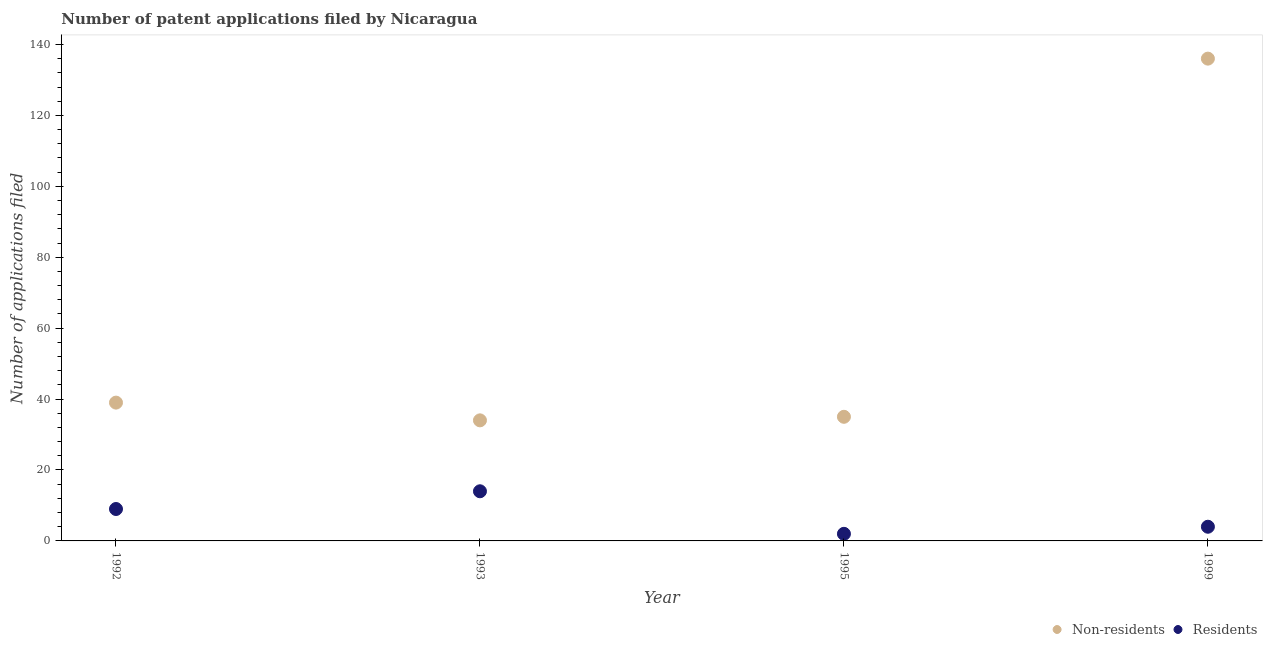How many different coloured dotlines are there?
Your answer should be compact. 2. Is the number of dotlines equal to the number of legend labels?
Your answer should be very brief. Yes. What is the number of patent applications by non residents in 1993?
Provide a succinct answer. 34. Across all years, what is the maximum number of patent applications by non residents?
Offer a terse response. 136. Across all years, what is the minimum number of patent applications by residents?
Provide a short and direct response. 2. In which year was the number of patent applications by non residents maximum?
Make the answer very short. 1999. What is the total number of patent applications by non residents in the graph?
Your answer should be compact. 244. What is the difference between the number of patent applications by residents in 1995 and that in 1999?
Offer a terse response. -2. What is the difference between the number of patent applications by non residents in 1999 and the number of patent applications by residents in 1992?
Provide a succinct answer. 127. What is the average number of patent applications by residents per year?
Your answer should be compact. 7.25. In the year 1999, what is the difference between the number of patent applications by non residents and number of patent applications by residents?
Offer a terse response. 132. What is the ratio of the number of patent applications by non residents in 1992 to that in 1995?
Provide a succinct answer. 1.11. Is the number of patent applications by non residents in 1992 less than that in 1993?
Your answer should be compact. No. What is the difference between the highest and the second highest number of patent applications by non residents?
Give a very brief answer. 97. What is the difference between the highest and the lowest number of patent applications by residents?
Give a very brief answer. 12. In how many years, is the number of patent applications by non residents greater than the average number of patent applications by non residents taken over all years?
Give a very brief answer. 1. How many dotlines are there?
Your answer should be compact. 2. How many years are there in the graph?
Your response must be concise. 4. Are the values on the major ticks of Y-axis written in scientific E-notation?
Offer a terse response. No. Does the graph contain any zero values?
Provide a short and direct response. No. Does the graph contain grids?
Provide a short and direct response. No. Where does the legend appear in the graph?
Offer a terse response. Bottom right. How many legend labels are there?
Make the answer very short. 2. How are the legend labels stacked?
Your answer should be very brief. Horizontal. What is the title of the graph?
Offer a very short reply. Number of patent applications filed by Nicaragua. What is the label or title of the Y-axis?
Provide a short and direct response. Number of applications filed. What is the Number of applications filed of Residents in 1992?
Provide a short and direct response. 9. What is the Number of applications filed in Non-residents in 1993?
Make the answer very short. 34. What is the Number of applications filed of Residents in 1995?
Offer a terse response. 2. What is the Number of applications filed of Non-residents in 1999?
Provide a succinct answer. 136. What is the Number of applications filed in Residents in 1999?
Your response must be concise. 4. Across all years, what is the maximum Number of applications filed of Non-residents?
Provide a succinct answer. 136. Across all years, what is the minimum Number of applications filed in Non-residents?
Your answer should be compact. 34. What is the total Number of applications filed in Non-residents in the graph?
Your response must be concise. 244. What is the total Number of applications filed of Residents in the graph?
Provide a succinct answer. 29. What is the difference between the Number of applications filed of Non-residents in 1992 and that in 1993?
Your answer should be compact. 5. What is the difference between the Number of applications filed of Non-residents in 1992 and that in 1995?
Offer a very short reply. 4. What is the difference between the Number of applications filed in Non-residents in 1992 and that in 1999?
Offer a terse response. -97. What is the difference between the Number of applications filed of Non-residents in 1993 and that in 1995?
Your response must be concise. -1. What is the difference between the Number of applications filed in Non-residents in 1993 and that in 1999?
Keep it short and to the point. -102. What is the difference between the Number of applications filed in Residents in 1993 and that in 1999?
Give a very brief answer. 10. What is the difference between the Number of applications filed of Non-residents in 1995 and that in 1999?
Your response must be concise. -101. What is the difference between the Number of applications filed of Residents in 1995 and that in 1999?
Your response must be concise. -2. What is the difference between the Number of applications filed of Non-residents in 1992 and the Number of applications filed of Residents in 1993?
Your response must be concise. 25. What is the difference between the Number of applications filed of Non-residents in 1992 and the Number of applications filed of Residents in 1995?
Give a very brief answer. 37. What is the difference between the Number of applications filed in Non-residents in 1992 and the Number of applications filed in Residents in 1999?
Provide a short and direct response. 35. What is the difference between the Number of applications filed in Non-residents in 1993 and the Number of applications filed in Residents in 1999?
Keep it short and to the point. 30. What is the average Number of applications filed of Non-residents per year?
Ensure brevity in your answer.  61. What is the average Number of applications filed of Residents per year?
Provide a succinct answer. 7.25. In the year 1993, what is the difference between the Number of applications filed in Non-residents and Number of applications filed in Residents?
Provide a succinct answer. 20. In the year 1995, what is the difference between the Number of applications filed in Non-residents and Number of applications filed in Residents?
Your answer should be very brief. 33. In the year 1999, what is the difference between the Number of applications filed of Non-residents and Number of applications filed of Residents?
Provide a short and direct response. 132. What is the ratio of the Number of applications filed in Non-residents in 1992 to that in 1993?
Offer a terse response. 1.15. What is the ratio of the Number of applications filed of Residents in 1992 to that in 1993?
Ensure brevity in your answer.  0.64. What is the ratio of the Number of applications filed in Non-residents in 1992 to that in 1995?
Your answer should be very brief. 1.11. What is the ratio of the Number of applications filed in Non-residents in 1992 to that in 1999?
Ensure brevity in your answer.  0.29. What is the ratio of the Number of applications filed of Residents in 1992 to that in 1999?
Your answer should be very brief. 2.25. What is the ratio of the Number of applications filed in Non-residents in 1993 to that in 1995?
Provide a succinct answer. 0.97. What is the ratio of the Number of applications filed in Non-residents in 1995 to that in 1999?
Your answer should be very brief. 0.26. What is the difference between the highest and the second highest Number of applications filed of Non-residents?
Your response must be concise. 97. What is the difference between the highest and the lowest Number of applications filed of Non-residents?
Make the answer very short. 102. What is the difference between the highest and the lowest Number of applications filed in Residents?
Your response must be concise. 12. 